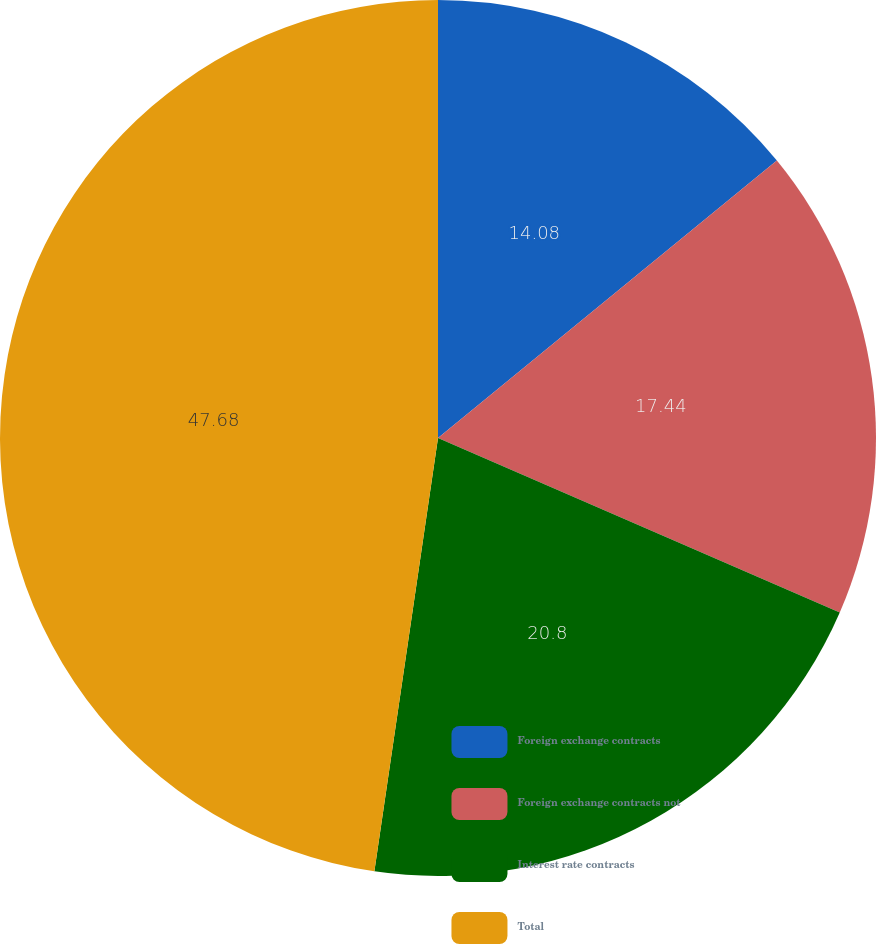Convert chart. <chart><loc_0><loc_0><loc_500><loc_500><pie_chart><fcel>Foreign exchange contracts<fcel>Foreign exchange contracts not<fcel>Interest rate contracts<fcel>Total<nl><fcel>14.08%<fcel>17.44%<fcel>20.8%<fcel>47.68%<nl></chart> 